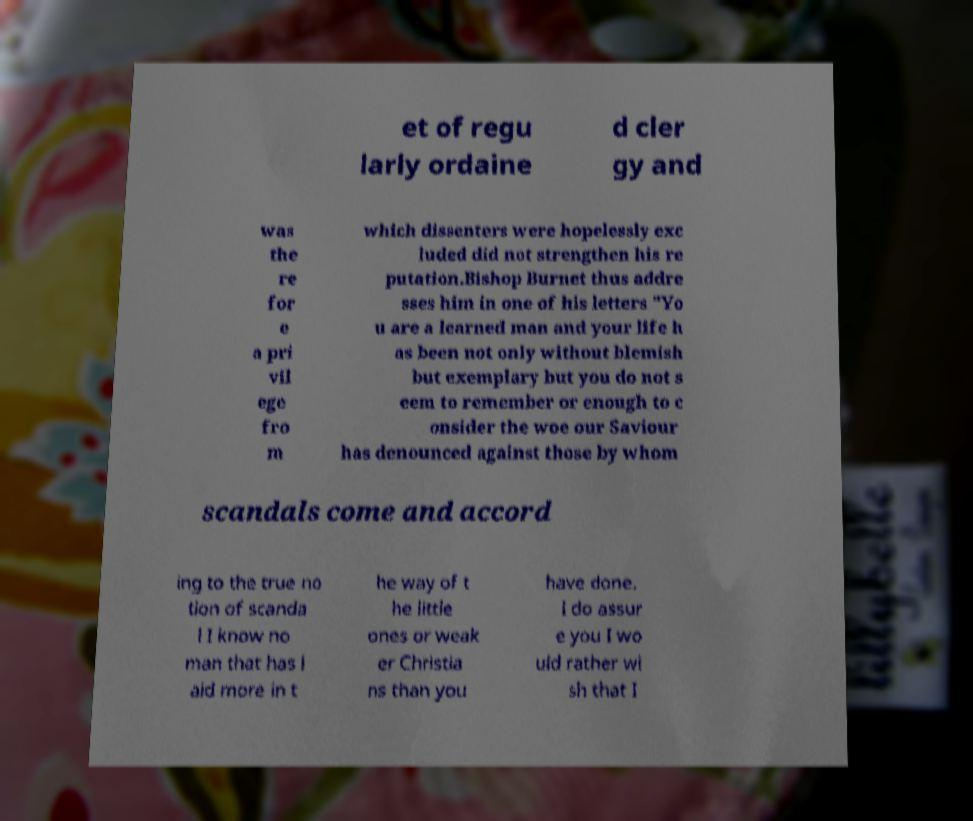For documentation purposes, I need the text within this image transcribed. Could you provide that? et of regu larly ordaine d cler gy and was the re for e a pri vil ege fro m which dissenters were hopelessly exc luded did not strengthen his re putation.Bishop Burnet thus addre sses him in one of his letters "Yo u are a learned man and your life h as been not only without blemish but exemplary but you do not s eem to remember or enough to c onsider the woe our Saviour has denounced against those by whom scandals come and accord ing to the true no tion of scanda l I know no man that has l aid more in t he way of t he little ones or weak er Christia ns than you have done. I do assur e you I wo uld rather wi sh that I 